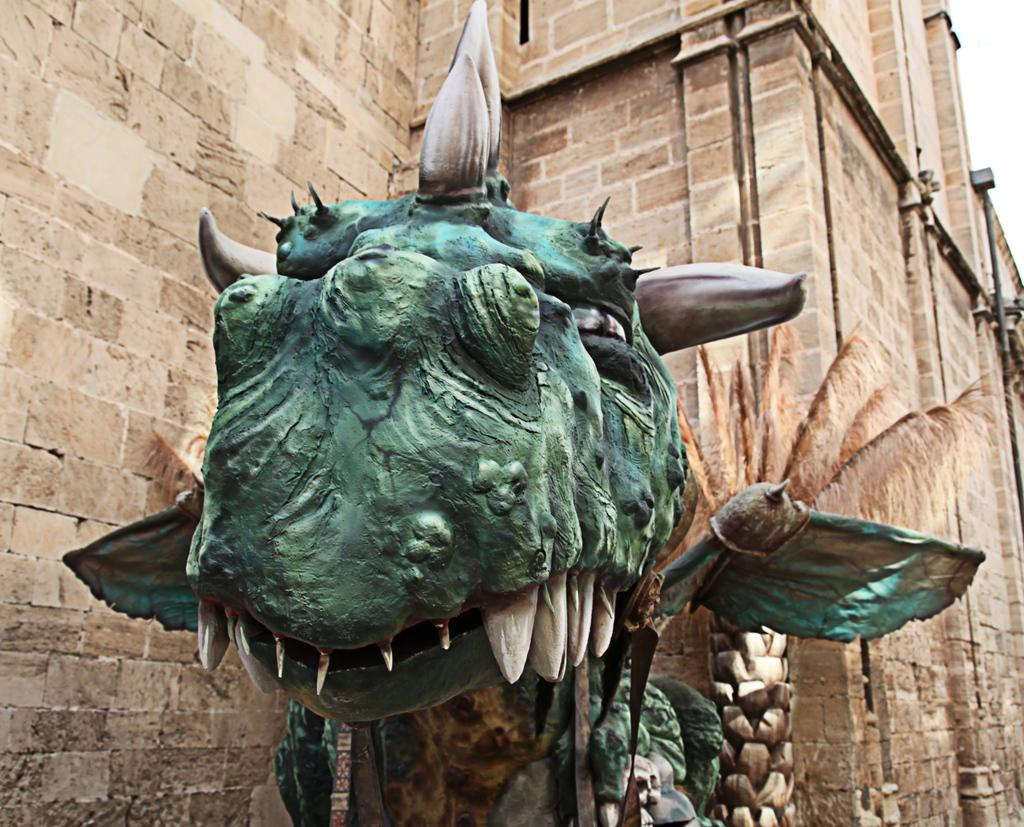What is the main subject in the middle of the image? There is a dragon statue in the middle of the image. What can be seen in the background of the image? There is a wall in the background of the image. What type of vegetation is on the right side of the image? There is a dry palm tree on the right side of the image, beside the wall. How many apples are hanging from the branches of the dry palm tree in the image? There are no apples present in the image, as the tree is a palm tree, which does not produce apples. 